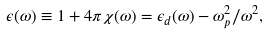<formula> <loc_0><loc_0><loc_500><loc_500>\epsilon ( \omega ) \equiv 1 + 4 \pi \chi ( \omega ) = \epsilon _ { d } ( \omega ) - \omega _ { p } ^ { 2 } / \omega ^ { 2 } ,</formula> 